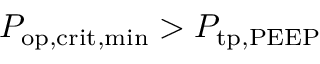Convert formula to latex. <formula><loc_0><loc_0><loc_500><loc_500>P _ { o p , c r i t , \min } > P _ { t p , P E E P }</formula> 